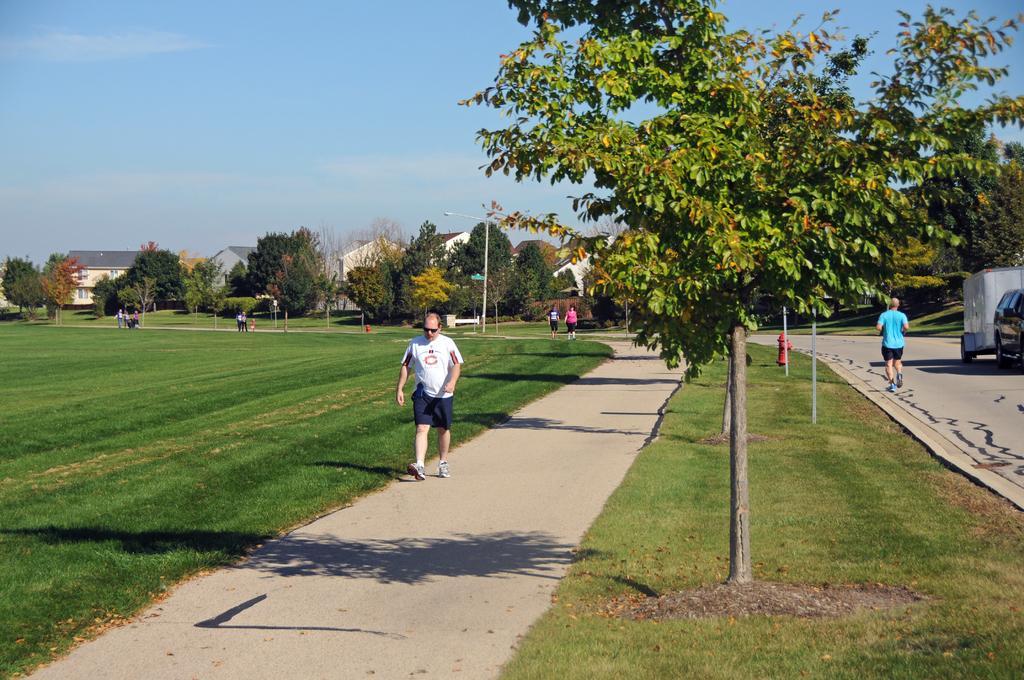Can you describe this image briefly? In this image I can see a person walking wearing white shirt, blue short. Background I can see few other persons walking, trees in green color, houses in white and cream color and sky in blue color. 